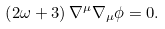Convert formula to latex. <formula><loc_0><loc_0><loc_500><loc_500>\left ( 2 \omega + 3 \right ) \nabla ^ { \mu } \nabla _ { \mu } \phi = 0 .</formula> 